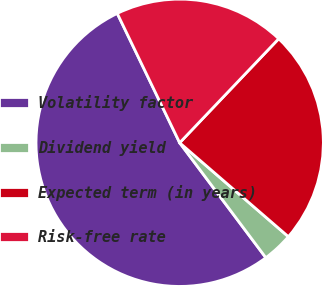Convert chart. <chart><loc_0><loc_0><loc_500><loc_500><pie_chart><fcel>Volatility factor<fcel>Dividend yield<fcel>Expected term (in years)<fcel>Risk-free rate<nl><fcel>53.08%<fcel>3.42%<fcel>24.23%<fcel>19.26%<nl></chart> 